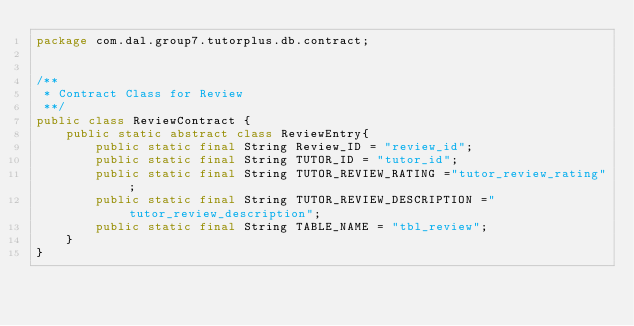Convert code to text. <code><loc_0><loc_0><loc_500><loc_500><_Java_>package com.dal.group7.tutorplus.db.contract;


/**
 * Contract Class for Review
 **/
public class ReviewContract {
    public static abstract class ReviewEntry{
        public static final String Review_ID = "review_id";
        public static final String TUTOR_ID = "tutor_id";
        public static final String TUTOR_REVIEW_RATING ="tutor_review_rating";
        public static final String TUTOR_REVIEW_DESCRIPTION ="tutor_review_description";
        public static final String TABLE_NAME = "tbl_review";
    }
}
</code> 